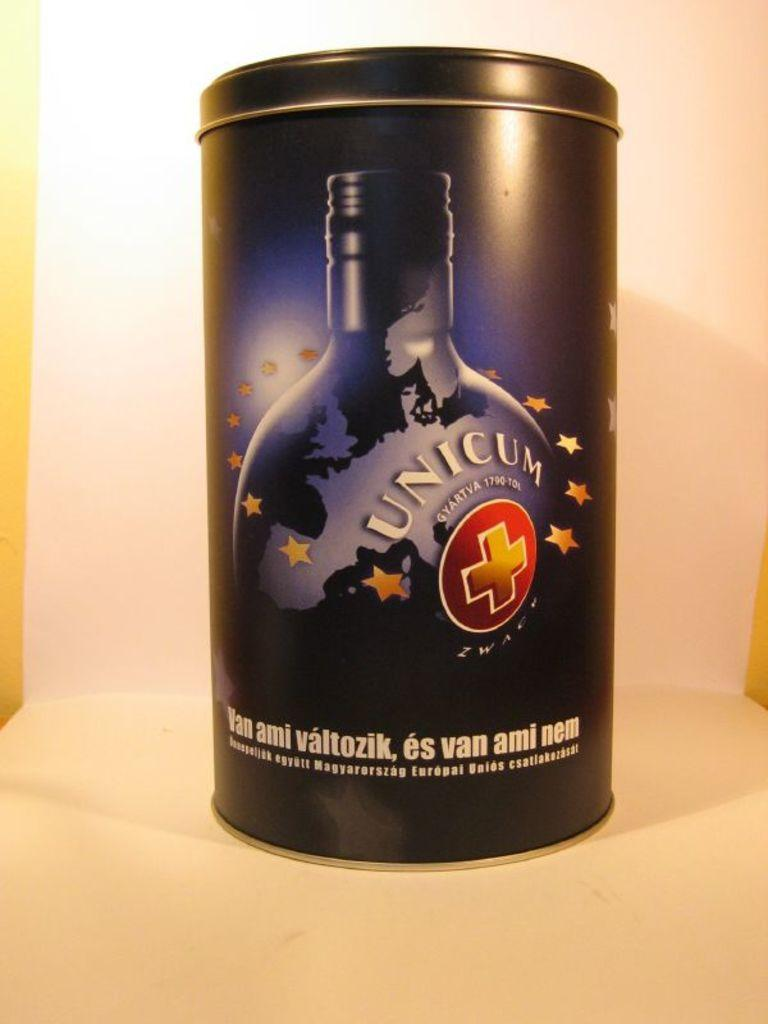<image>
Offer a succinct explanation of the picture presented. A close up of a tin of Unicum +. 